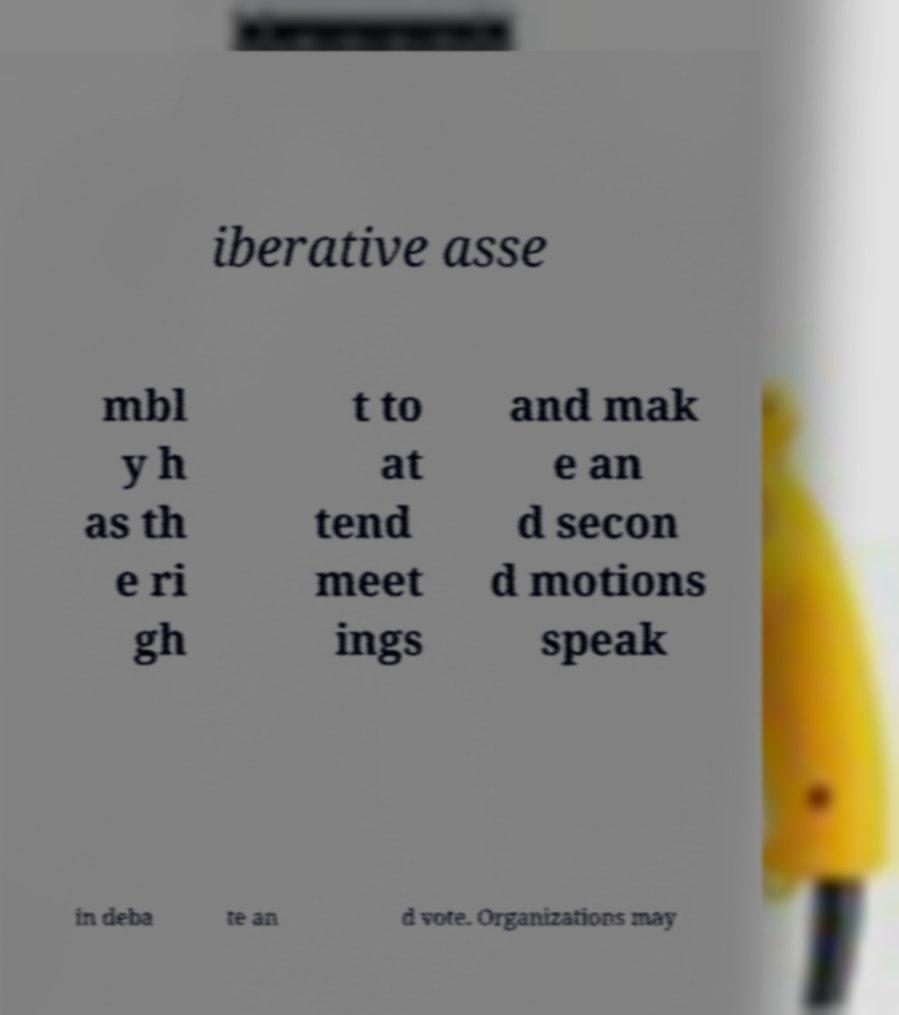Could you assist in decoding the text presented in this image and type it out clearly? iberative asse mbl y h as th e ri gh t to at tend meet ings and mak e an d secon d motions speak in deba te an d vote. Organizations may 